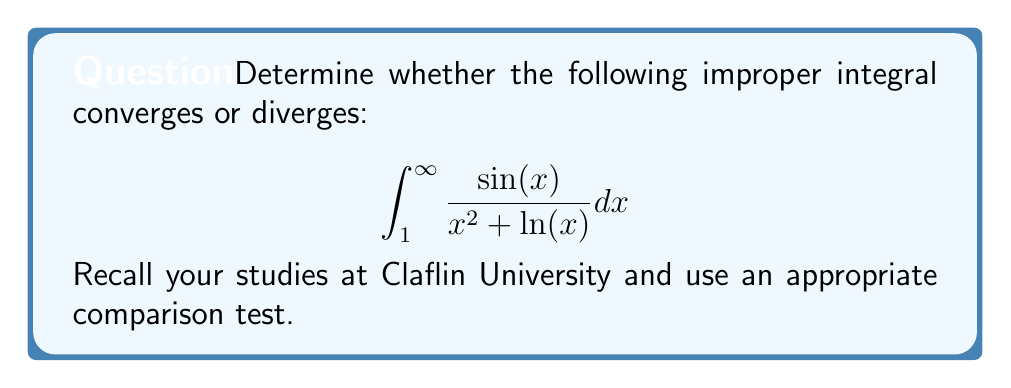What is the answer to this math problem? Let's approach this step-by-step using a comparison test:

1) First, observe that for $x \geq 1$, we have $\ln(x) \geq 0$. Therefore:

   $$x^2 + \ln(x) \geq x^2$$

2) This implies:

   $$\frac{1}{x^2 + \ln(x)} \leq \frac{1}{x^2}$$

3) We also know that $|\sin(x)| \leq 1$ for all $x$. Therefore:

   $$\left|\frac{\sin(x)}{x^2 + \ln(x)}\right| \leq \frac{1}{x^2}$$

4) Now, we can apply the comparison test. We know that:

   $$\int_1^{\infty} \frac{1}{x^2} dx$$

   converges (this is a p-series with $p=2 > 1$).

5) Since our original integrand is bounded in absolute value by an integrable function, by the comparison test, we can conclude that:

   $$\int_1^{\infty} \frac{\sin(x)}{x^2 + \ln(x)} dx$$

   also converges absolutely, and therefore converges.
Answer: The improper integral $\int_1^{\infty} \frac{\sin(x)}{x^2 + \ln(x)} dx$ converges. 